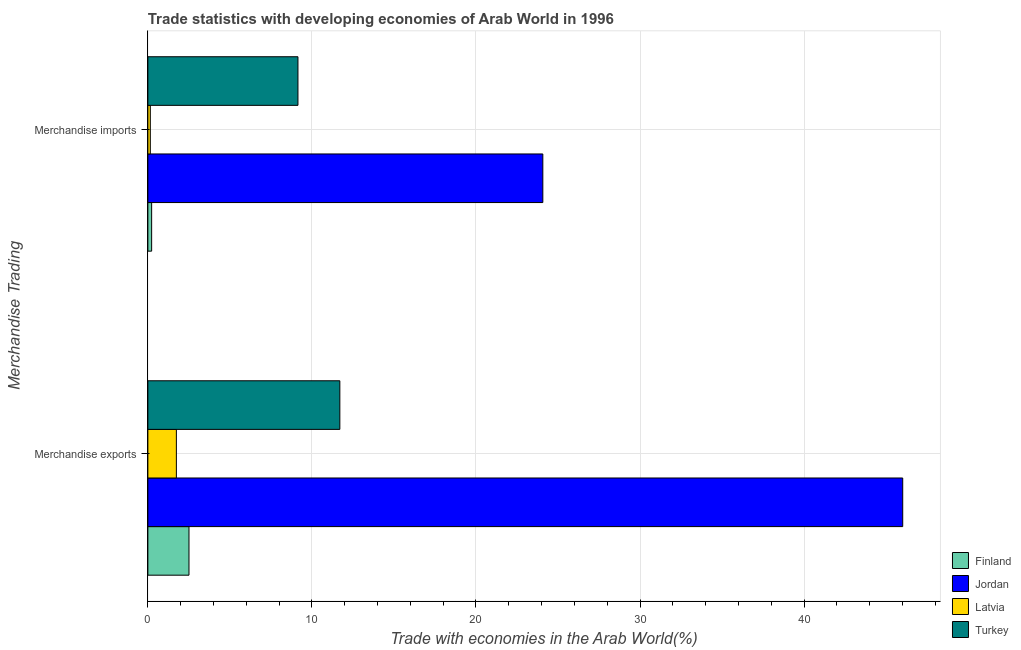How many groups of bars are there?
Offer a very short reply. 2. Are the number of bars per tick equal to the number of legend labels?
Your answer should be compact. Yes. Are the number of bars on each tick of the Y-axis equal?
Your answer should be very brief. Yes. How many bars are there on the 1st tick from the top?
Offer a terse response. 4. How many bars are there on the 1st tick from the bottom?
Keep it short and to the point. 4. What is the label of the 2nd group of bars from the top?
Your answer should be compact. Merchandise exports. What is the merchandise imports in Latvia?
Make the answer very short. 0.15. Across all countries, what is the maximum merchandise imports?
Keep it short and to the point. 24.07. Across all countries, what is the minimum merchandise exports?
Provide a succinct answer. 1.74. In which country was the merchandise exports maximum?
Offer a terse response. Jordan. In which country was the merchandise imports minimum?
Provide a succinct answer. Latvia. What is the total merchandise exports in the graph?
Offer a terse response. 61.96. What is the difference between the merchandise imports in Finland and that in Latvia?
Ensure brevity in your answer.  0.08. What is the difference between the merchandise exports in Finland and the merchandise imports in Turkey?
Provide a short and direct response. -6.64. What is the average merchandise imports per country?
Offer a terse response. 8.4. What is the difference between the merchandise exports and merchandise imports in Jordan?
Provide a short and direct response. 21.94. What is the ratio of the merchandise exports in Latvia to that in Finland?
Provide a short and direct response. 0.69. Is the merchandise exports in Latvia less than that in Jordan?
Keep it short and to the point. Yes. What does the 1st bar from the top in Merchandise imports represents?
Offer a terse response. Turkey. Are the values on the major ticks of X-axis written in scientific E-notation?
Your answer should be very brief. No. Where does the legend appear in the graph?
Offer a very short reply. Bottom right. What is the title of the graph?
Keep it short and to the point. Trade statistics with developing economies of Arab World in 1996. What is the label or title of the X-axis?
Provide a succinct answer. Trade with economies in the Arab World(%). What is the label or title of the Y-axis?
Ensure brevity in your answer.  Merchandise Trading. What is the Trade with economies in the Arab World(%) in Finland in Merchandise exports?
Your response must be concise. 2.51. What is the Trade with economies in the Arab World(%) in Jordan in Merchandise exports?
Offer a very short reply. 46.01. What is the Trade with economies in the Arab World(%) in Latvia in Merchandise exports?
Make the answer very short. 1.74. What is the Trade with economies in the Arab World(%) of Turkey in Merchandise exports?
Your answer should be compact. 11.7. What is the Trade with economies in the Arab World(%) in Finland in Merchandise imports?
Give a very brief answer. 0.23. What is the Trade with economies in the Arab World(%) in Jordan in Merchandise imports?
Give a very brief answer. 24.07. What is the Trade with economies in the Arab World(%) of Latvia in Merchandise imports?
Offer a terse response. 0.15. What is the Trade with economies in the Arab World(%) in Turkey in Merchandise imports?
Offer a very short reply. 9.15. Across all Merchandise Trading, what is the maximum Trade with economies in the Arab World(%) of Finland?
Keep it short and to the point. 2.51. Across all Merchandise Trading, what is the maximum Trade with economies in the Arab World(%) of Jordan?
Your answer should be very brief. 46.01. Across all Merchandise Trading, what is the maximum Trade with economies in the Arab World(%) in Latvia?
Your answer should be compact. 1.74. Across all Merchandise Trading, what is the maximum Trade with economies in the Arab World(%) in Turkey?
Keep it short and to the point. 11.7. Across all Merchandise Trading, what is the minimum Trade with economies in the Arab World(%) of Finland?
Offer a terse response. 0.23. Across all Merchandise Trading, what is the minimum Trade with economies in the Arab World(%) in Jordan?
Your answer should be very brief. 24.07. Across all Merchandise Trading, what is the minimum Trade with economies in the Arab World(%) in Latvia?
Make the answer very short. 0.15. Across all Merchandise Trading, what is the minimum Trade with economies in the Arab World(%) of Turkey?
Ensure brevity in your answer.  9.15. What is the total Trade with economies in the Arab World(%) of Finland in the graph?
Give a very brief answer. 2.74. What is the total Trade with economies in the Arab World(%) in Jordan in the graph?
Your answer should be compact. 70.09. What is the total Trade with economies in the Arab World(%) in Latvia in the graph?
Ensure brevity in your answer.  1.89. What is the total Trade with economies in the Arab World(%) in Turkey in the graph?
Give a very brief answer. 20.85. What is the difference between the Trade with economies in the Arab World(%) of Finland in Merchandise exports and that in Merchandise imports?
Make the answer very short. 2.28. What is the difference between the Trade with economies in the Arab World(%) of Jordan in Merchandise exports and that in Merchandise imports?
Offer a very short reply. 21.94. What is the difference between the Trade with economies in the Arab World(%) of Latvia in Merchandise exports and that in Merchandise imports?
Offer a very short reply. 1.59. What is the difference between the Trade with economies in the Arab World(%) of Turkey in Merchandise exports and that in Merchandise imports?
Ensure brevity in your answer.  2.55. What is the difference between the Trade with economies in the Arab World(%) in Finland in Merchandise exports and the Trade with economies in the Arab World(%) in Jordan in Merchandise imports?
Your answer should be compact. -21.57. What is the difference between the Trade with economies in the Arab World(%) of Finland in Merchandise exports and the Trade with economies in the Arab World(%) of Latvia in Merchandise imports?
Make the answer very short. 2.36. What is the difference between the Trade with economies in the Arab World(%) in Finland in Merchandise exports and the Trade with economies in the Arab World(%) in Turkey in Merchandise imports?
Your response must be concise. -6.64. What is the difference between the Trade with economies in the Arab World(%) of Jordan in Merchandise exports and the Trade with economies in the Arab World(%) of Latvia in Merchandise imports?
Keep it short and to the point. 45.86. What is the difference between the Trade with economies in the Arab World(%) in Jordan in Merchandise exports and the Trade with economies in the Arab World(%) in Turkey in Merchandise imports?
Provide a short and direct response. 36.86. What is the difference between the Trade with economies in the Arab World(%) of Latvia in Merchandise exports and the Trade with economies in the Arab World(%) of Turkey in Merchandise imports?
Make the answer very short. -7.41. What is the average Trade with economies in the Arab World(%) of Finland per Merchandise Trading?
Make the answer very short. 1.37. What is the average Trade with economies in the Arab World(%) in Jordan per Merchandise Trading?
Give a very brief answer. 35.04. What is the average Trade with economies in the Arab World(%) of Latvia per Merchandise Trading?
Offer a very short reply. 0.94. What is the average Trade with economies in the Arab World(%) of Turkey per Merchandise Trading?
Make the answer very short. 10.43. What is the difference between the Trade with economies in the Arab World(%) of Finland and Trade with economies in the Arab World(%) of Jordan in Merchandise exports?
Make the answer very short. -43.51. What is the difference between the Trade with economies in the Arab World(%) of Finland and Trade with economies in the Arab World(%) of Latvia in Merchandise exports?
Your answer should be compact. 0.77. What is the difference between the Trade with economies in the Arab World(%) in Finland and Trade with economies in the Arab World(%) in Turkey in Merchandise exports?
Your answer should be very brief. -9.2. What is the difference between the Trade with economies in the Arab World(%) in Jordan and Trade with economies in the Arab World(%) in Latvia in Merchandise exports?
Ensure brevity in your answer.  44.27. What is the difference between the Trade with economies in the Arab World(%) in Jordan and Trade with economies in the Arab World(%) in Turkey in Merchandise exports?
Keep it short and to the point. 34.31. What is the difference between the Trade with economies in the Arab World(%) in Latvia and Trade with economies in the Arab World(%) in Turkey in Merchandise exports?
Keep it short and to the point. -9.96. What is the difference between the Trade with economies in the Arab World(%) of Finland and Trade with economies in the Arab World(%) of Jordan in Merchandise imports?
Provide a succinct answer. -23.85. What is the difference between the Trade with economies in the Arab World(%) of Finland and Trade with economies in the Arab World(%) of Latvia in Merchandise imports?
Provide a short and direct response. 0.08. What is the difference between the Trade with economies in the Arab World(%) in Finland and Trade with economies in the Arab World(%) in Turkey in Merchandise imports?
Offer a very short reply. -8.92. What is the difference between the Trade with economies in the Arab World(%) of Jordan and Trade with economies in the Arab World(%) of Latvia in Merchandise imports?
Offer a very short reply. 23.93. What is the difference between the Trade with economies in the Arab World(%) in Jordan and Trade with economies in the Arab World(%) in Turkey in Merchandise imports?
Keep it short and to the point. 14.93. What is the difference between the Trade with economies in the Arab World(%) of Latvia and Trade with economies in the Arab World(%) of Turkey in Merchandise imports?
Keep it short and to the point. -9. What is the ratio of the Trade with economies in the Arab World(%) in Finland in Merchandise exports to that in Merchandise imports?
Ensure brevity in your answer.  10.91. What is the ratio of the Trade with economies in the Arab World(%) of Jordan in Merchandise exports to that in Merchandise imports?
Provide a succinct answer. 1.91. What is the ratio of the Trade with economies in the Arab World(%) in Latvia in Merchandise exports to that in Merchandise imports?
Provide a short and direct response. 11.67. What is the ratio of the Trade with economies in the Arab World(%) in Turkey in Merchandise exports to that in Merchandise imports?
Provide a short and direct response. 1.28. What is the difference between the highest and the second highest Trade with economies in the Arab World(%) in Finland?
Offer a very short reply. 2.28. What is the difference between the highest and the second highest Trade with economies in the Arab World(%) in Jordan?
Ensure brevity in your answer.  21.94. What is the difference between the highest and the second highest Trade with economies in the Arab World(%) of Latvia?
Ensure brevity in your answer.  1.59. What is the difference between the highest and the second highest Trade with economies in the Arab World(%) of Turkey?
Offer a very short reply. 2.55. What is the difference between the highest and the lowest Trade with economies in the Arab World(%) of Finland?
Your answer should be very brief. 2.28. What is the difference between the highest and the lowest Trade with economies in the Arab World(%) of Jordan?
Provide a short and direct response. 21.94. What is the difference between the highest and the lowest Trade with economies in the Arab World(%) of Latvia?
Your answer should be compact. 1.59. What is the difference between the highest and the lowest Trade with economies in the Arab World(%) in Turkey?
Give a very brief answer. 2.55. 